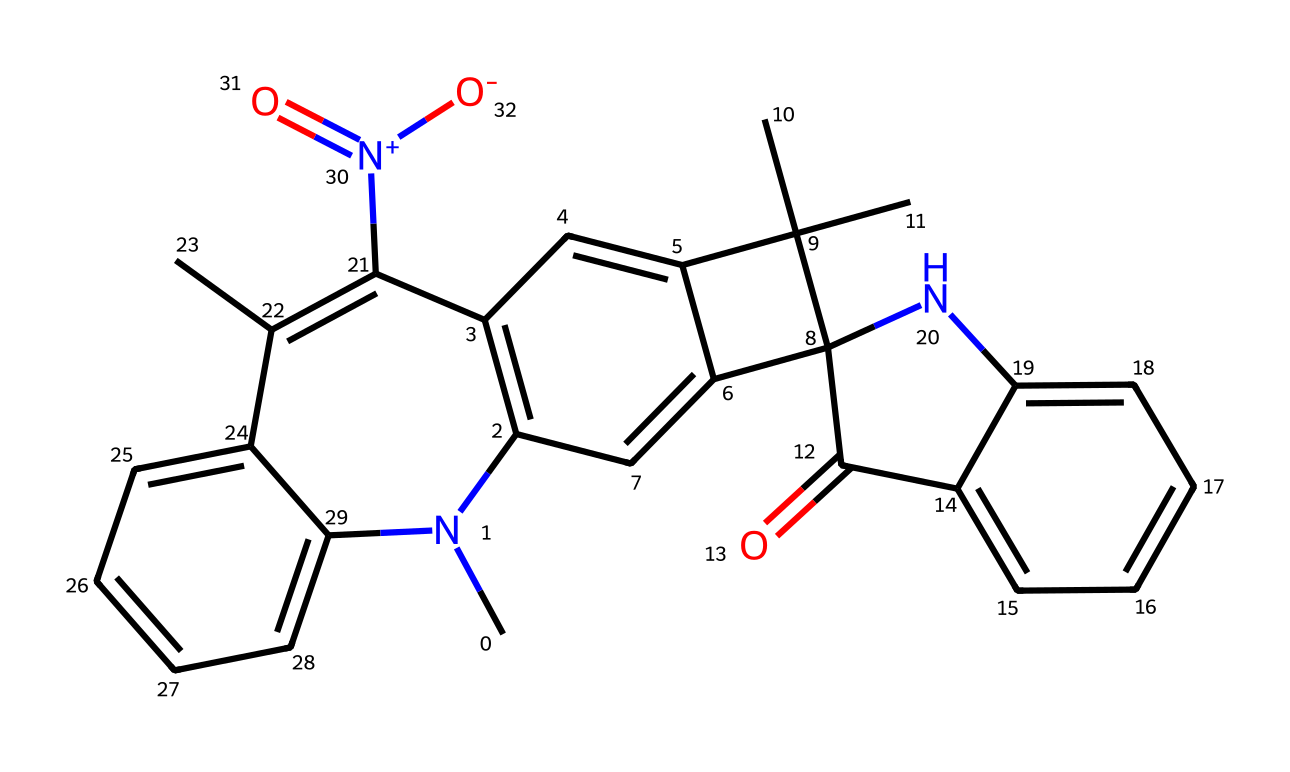What is the total number of carbon atoms in this chemical structure? By examining the SMILES representation, we can identify each carbon atom in the structure. Each letter "C" represents a carbon atom, and based on the structure, there are 27 carbon atoms.
Answer: 27 How many nitrogen atoms are present in this chemical? Looking at the SMILES notation, the letter "N" represents nitrogen atoms. By counting the occurrences of "N," we find there are 3 nitrogen atoms in the structure.
Answer: 3 What functional group is present in this chemical that contributes to its photochromic properties? The presence of the [N+](=O)[O-] in the structure indicates a nitro group, which is commonly associated with photoreactive characteristics, especially in photochromic chemicals.
Answer: nitro group Does this chemical structure contain any double bonds? By analyzing the SMILES notation, the "=" sign between atoms indicates the presence of double bonds. Examining the structure confirms multiple double bonds exist throughout the molecule.
Answer: yes Which part of this molecule is likely to provide its photoreactivity? The presence of the nitro group ([N+](=O)[O-]) and its conjugated structure means this portion of the molecule is highly involved in the photoreactive process when exposed to UV light.
Answer: nitro group What indicates that this chemical can change its structure upon light exposure? The presence of multiple conjugated double bonds and the ability of the nitro group to undergo electronic transitions under UV light signals that this molecule can change its structure when exposed to light.
Answer: conjugated double bonds How many rings are present in this chemical structure? By carefully analyzing the SMILES representation, we can observe the presence of several enclosed structures indicated by the numbers. Counting these indicates there are four rings in the molecule.
Answer: 4 